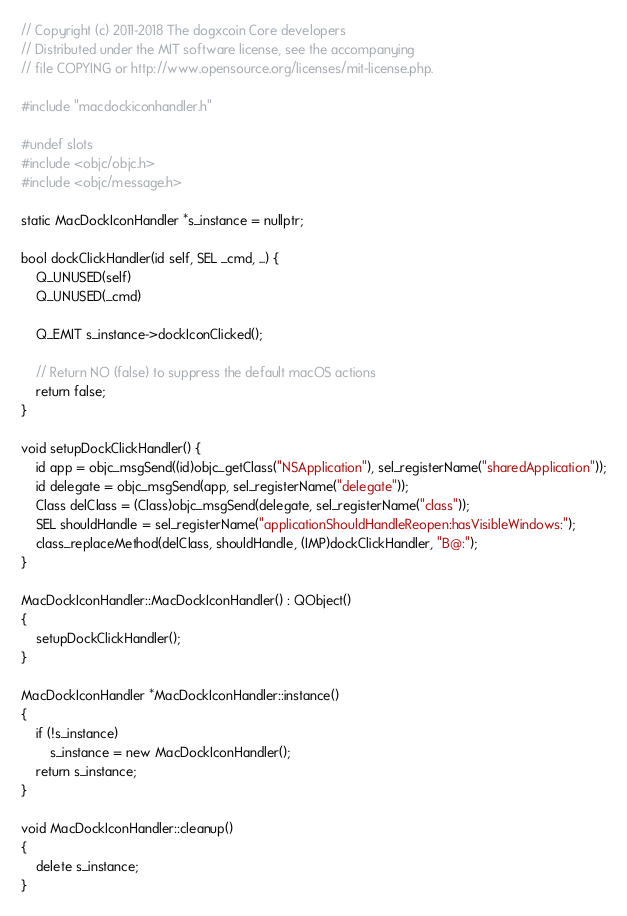Convert code to text. <code><loc_0><loc_0><loc_500><loc_500><_ObjectiveC_>// Copyright (c) 2011-2018 The dogxcoin Core developers
// Distributed under the MIT software license, see the accompanying
// file COPYING or http://www.opensource.org/licenses/mit-license.php.

#include "macdockiconhandler.h"

#undef slots
#include <objc/objc.h>
#include <objc/message.h>

static MacDockIconHandler *s_instance = nullptr;

bool dockClickHandler(id self, SEL _cmd, ...) {
    Q_UNUSED(self)
    Q_UNUSED(_cmd)

    Q_EMIT s_instance->dockIconClicked();

    // Return NO (false) to suppress the default macOS actions
    return false;
}

void setupDockClickHandler() {
    id app = objc_msgSend((id)objc_getClass("NSApplication"), sel_registerName("sharedApplication"));
    id delegate = objc_msgSend(app, sel_registerName("delegate"));
    Class delClass = (Class)objc_msgSend(delegate, sel_registerName("class"));
    SEL shouldHandle = sel_registerName("applicationShouldHandleReopen:hasVisibleWindows:");
    class_replaceMethod(delClass, shouldHandle, (IMP)dockClickHandler, "B@:");
}

MacDockIconHandler::MacDockIconHandler() : QObject()
{
    setupDockClickHandler();
}

MacDockIconHandler *MacDockIconHandler::instance()
{
    if (!s_instance)
        s_instance = new MacDockIconHandler();
    return s_instance;
}

void MacDockIconHandler::cleanup()
{
    delete s_instance;
}
</code> 